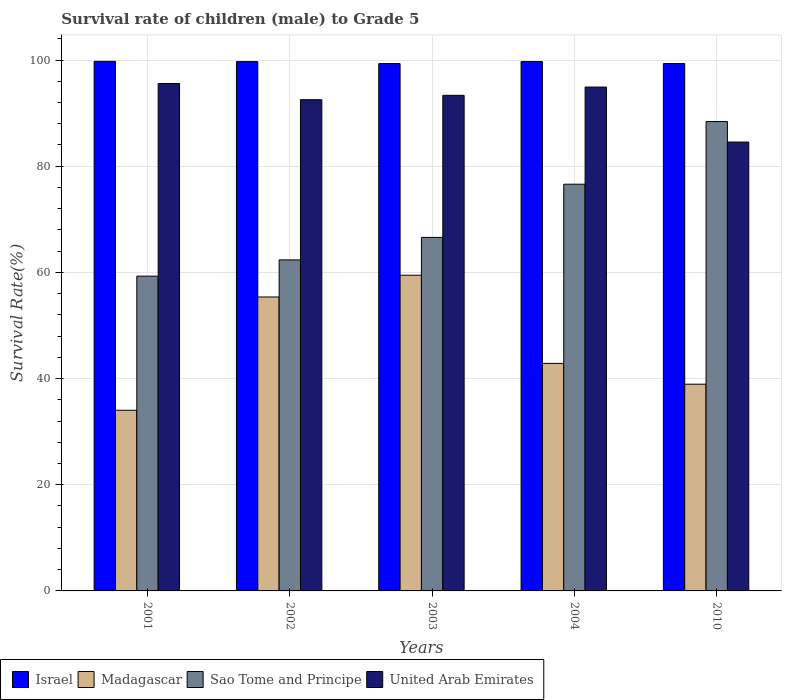How many groups of bars are there?
Provide a short and direct response. 5. Are the number of bars per tick equal to the number of legend labels?
Keep it short and to the point. Yes. Are the number of bars on each tick of the X-axis equal?
Your answer should be very brief. Yes. How many bars are there on the 4th tick from the left?
Your answer should be compact. 4. How many bars are there on the 3rd tick from the right?
Make the answer very short. 4. What is the survival rate of male children to grade 5 in Israel in 2010?
Your answer should be very brief. 99.33. Across all years, what is the maximum survival rate of male children to grade 5 in Sao Tome and Principe?
Give a very brief answer. 88.42. Across all years, what is the minimum survival rate of male children to grade 5 in Sao Tome and Principe?
Keep it short and to the point. 59.29. What is the total survival rate of male children to grade 5 in Sao Tome and Principe in the graph?
Make the answer very short. 353.26. What is the difference between the survival rate of male children to grade 5 in Madagascar in 2001 and that in 2004?
Offer a terse response. -8.83. What is the difference between the survival rate of male children to grade 5 in Sao Tome and Principe in 2001 and the survival rate of male children to grade 5 in Israel in 2004?
Make the answer very short. -40.42. What is the average survival rate of male children to grade 5 in Sao Tome and Principe per year?
Offer a terse response. 70.65. In the year 2002, what is the difference between the survival rate of male children to grade 5 in Israel and survival rate of male children to grade 5 in Madagascar?
Your answer should be very brief. 44.34. In how many years, is the survival rate of male children to grade 5 in United Arab Emirates greater than 84 %?
Ensure brevity in your answer.  5. What is the ratio of the survival rate of male children to grade 5 in Sao Tome and Principe in 2003 to that in 2010?
Your answer should be compact. 0.75. Is the survival rate of male children to grade 5 in Israel in 2001 less than that in 2004?
Your answer should be compact. No. What is the difference between the highest and the second highest survival rate of male children to grade 5 in Madagascar?
Offer a very short reply. 4.1. What is the difference between the highest and the lowest survival rate of male children to grade 5 in Israel?
Ensure brevity in your answer.  0.42. In how many years, is the survival rate of male children to grade 5 in Madagascar greater than the average survival rate of male children to grade 5 in Madagascar taken over all years?
Your answer should be very brief. 2. Is the sum of the survival rate of male children to grade 5 in United Arab Emirates in 2002 and 2010 greater than the maximum survival rate of male children to grade 5 in Madagascar across all years?
Keep it short and to the point. Yes. Is it the case that in every year, the sum of the survival rate of male children to grade 5 in United Arab Emirates and survival rate of male children to grade 5 in Madagascar is greater than the sum of survival rate of male children to grade 5 in Sao Tome and Principe and survival rate of male children to grade 5 in Israel?
Provide a succinct answer. Yes. What does the 4th bar from the left in 2001 represents?
Your answer should be very brief. United Arab Emirates. Are all the bars in the graph horizontal?
Make the answer very short. No. How many years are there in the graph?
Provide a succinct answer. 5. What is the difference between two consecutive major ticks on the Y-axis?
Keep it short and to the point. 20. What is the title of the graph?
Give a very brief answer. Survival rate of children (male) to Grade 5. What is the label or title of the X-axis?
Offer a very short reply. Years. What is the label or title of the Y-axis?
Provide a short and direct response. Survival Rate(%). What is the Survival Rate(%) in Israel in 2001?
Keep it short and to the point. 99.75. What is the Survival Rate(%) in Madagascar in 2001?
Offer a terse response. 34.03. What is the Survival Rate(%) of Sao Tome and Principe in 2001?
Offer a terse response. 59.29. What is the Survival Rate(%) of United Arab Emirates in 2001?
Offer a terse response. 95.57. What is the Survival Rate(%) in Israel in 2002?
Offer a very short reply. 99.71. What is the Survival Rate(%) of Madagascar in 2002?
Your response must be concise. 55.37. What is the Survival Rate(%) of Sao Tome and Principe in 2002?
Give a very brief answer. 62.35. What is the Survival Rate(%) of United Arab Emirates in 2002?
Make the answer very short. 92.53. What is the Survival Rate(%) of Israel in 2003?
Ensure brevity in your answer.  99.33. What is the Survival Rate(%) in Madagascar in 2003?
Your answer should be very brief. 59.47. What is the Survival Rate(%) in Sao Tome and Principe in 2003?
Provide a short and direct response. 66.59. What is the Survival Rate(%) in United Arab Emirates in 2003?
Offer a very short reply. 93.35. What is the Survival Rate(%) in Israel in 2004?
Give a very brief answer. 99.72. What is the Survival Rate(%) in Madagascar in 2004?
Provide a short and direct response. 42.86. What is the Survival Rate(%) in Sao Tome and Principe in 2004?
Offer a terse response. 76.61. What is the Survival Rate(%) in United Arab Emirates in 2004?
Keep it short and to the point. 94.91. What is the Survival Rate(%) in Israel in 2010?
Ensure brevity in your answer.  99.33. What is the Survival Rate(%) of Madagascar in 2010?
Give a very brief answer. 38.94. What is the Survival Rate(%) in Sao Tome and Principe in 2010?
Give a very brief answer. 88.42. What is the Survival Rate(%) of United Arab Emirates in 2010?
Make the answer very short. 84.55. Across all years, what is the maximum Survival Rate(%) of Israel?
Offer a very short reply. 99.75. Across all years, what is the maximum Survival Rate(%) in Madagascar?
Your answer should be very brief. 59.47. Across all years, what is the maximum Survival Rate(%) of Sao Tome and Principe?
Keep it short and to the point. 88.42. Across all years, what is the maximum Survival Rate(%) of United Arab Emirates?
Provide a short and direct response. 95.57. Across all years, what is the minimum Survival Rate(%) of Israel?
Make the answer very short. 99.33. Across all years, what is the minimum Survival Rate(%) of Madagascar?
Ensure brevity in your answer.  34.03. Across all years, what is the minimum Survival Rate(%) of Sao Tome and Principe?
Offer a terse response. 59.29. Across all years, what is the minimum Survival Rate(%) of United Arab Emirates?
Provide a succinct answer. 84.55. What is the total Survival Rate(%) of Israel in the graph?
Offer a terse response. 497.84. What is the total Survival Rate(%) of Madagascar in the graph?
Ensure brevity in your answer.  230.66. What is the total Survival Rate(%) of Sao Tome and Principe in the graph?
Offer a terse response. 353.26. What is the total Survival Rate(%) in United Arab Emirates in the graph?
Offer a terse response. 460.92. What is the difference between the Survival Rate(%) of Israel in 2001 and that in 2002?
Offer a very short reply. 0.05. What is the difference between the Survival Rate(%) in Madagascar in 2001 and that in 2002?
Keep it short and to the point. -21.34. What is the difference between the Survival Rate(%) in Sao Tome and Principe in 2001 and that in 2002?
Keep it short and to the point. -3.06. What is the difference between the Survival Rate(%) of United Arab Emirates in 2001 and that in 2002?
Provide a succinct answer. 3.04. What is the difference between the Survival Rate(%) in Israel in 2001 and that in 2003?
Provide a short and direct response. 0.42. What is the difference between the Survival Rate(%) in Madagascar in 2001 and that in 2003?
Your response must be concise. -25.44. What is the difference between the Survival Rate(%) of Sao Tome and Principe in 2001 and that in 2003?
Your answer should be very brief. -7.3. What is the difference between the Survival Rate(%) in United Arab Emirates in 2001 and that in 2003?
Make the answer very short. 2.22. What is the difference between the Survival Rate(%) of Israel in 2001 and that in 2004?
Keep it short and to the point. 0.04. What is the difference between the Survival Rate(%) of Madagascar in 2001 and that in 2004?
Offer a very short reply. -8.83. What is the difference between the Survival Rate(%) in Sao Tome and Principe in 2001 and that in 2004?
Ensure brevity in your answer.  -17.32. What is the difference between the Survival Rate(%) in United Arab Emirates in 2001 and that in 2004?
Provide a succinct answer. 0.66. What is the difference between the Survival Rate(%) of Israel in 2001 and that in 2010?
Provide a short and direct response. 0.42. What is the difference between the Survival Rate(%) in Madagascar in 2001 and that in 2010?
Provide a short and direct response. -4.91. What is the difference between the Survival Rate(%) of Sao Tome and Principe in 2001 and that in 2010?
Give a very brief answer. -29.13. What is the difference between the Survival Rate(%) of United Arab Emirates in 2001 and that in 2010?
Your answer should be very brief. 11.03. What is the difference between the Survival Rate(%) in Israel in 2002 and that in 2003?
Ensure brevity in your answer.  0.37. What is the difference between the Survival Rate(%) of Madagascar in 2002 and that in 2003?
Give a very brief answer. -4.1. What is the difference between the Survival Rate(%) of Sao Tome and Principe in 2002 and that in 2003?
Your answer should be compact. -4.24. What is the difference between the Survival Rate(%) of United Arab Emirates in 2002 and that in 2003?
Your response must be concise. -0.82. What is the difference between the Survival Rate(%) in Israel in 2002 and that in 2004?
Provide a short and direct response. -0.01. What is the difference between the Survival Rate(%) of Madagascar in 2002 and that in 2004?
Offer a very short reply. 12.51. What is the difference between the Survival Rate(%) of Sao Tome and Principe in 2002 and that in 2004?
Ensure brevity in your answer.  -14.26. What is the difference between the Survival Rate(%) of United Arab Emirates in 2002 and that in 2004?
Your response must be concise. -2.38. What is the difference between the Survival Rate(%) of Israel in 2002 and that in 2010?
Offer a very short reply. 0.37. What is the difference between the Survival Rate(%) in Madagascar in 2002 and that in 2010?
Ensure brevity in your answer.  16.43. What is the difference between the Survival Rate(%) of Sao Tome and Principe in 2002 and that in 2010?
Provide a short and direct response. -26.07. What is the difference between the Survival Rate(%) in United Arab Emirates in 2002 and that in 2010?
Your response must be concise. 7.98. What is the difference between the Survival Rate(%) in Israel in 2003 and that in 2004?
Your answer should be compact. -0.39. What is the difference between the Survival Rate(%) in Madagascar in 2003 and that in 2004?
Make the answer very short. 16.61. What is the difference between the Survival Rate(%) of Sao Tome and Principe in 2003 and that in 2004?
Ensure brevity in your answer.  -10.02. What is the difference between the Survival Rate(%) of United Arab Emirates in 2003 and that in 2004?
Offer a very short reply. -1.56. What is the difference between the Survival Rate(%) in Israel in 2003 and that in 2010?
Make the answer very short. -0. What is the difference between the Survival Rate(%) of Madagascar in 2003 and that in 2010?
Offer a very short reply. 20.53. What is the difference between the Survival Rate(%) in Sao Tome and Principe in 2003 and that in 2010?
Make the answer very short. -21.83. What is the difference between the Survival Rate(%) of United Arab Emirates in 2003 and that in 2010?
Offer a terse response. 8.8. What is the difference between the Survival Rate(%) in Israel in 2004 and that in 2010?
Keep it short and to the point. 0.38. What is the difference between the Survival Rate(%) of Madagascar in 2004 and that in 2010?
Provide a succinct answer. 3.92. What is the difference between the Survival Rate(%) of Sao Tome and Principe in 2004 and that in 2010?
Your answer should be compact. -11.81. What is the difference between the Survival Rate(%) in United Arab Emirates in 2004 and that in 2010?
Offer a terse response. 10.36. What is the difference between the Survival Rate(%) of Israel in 2001 and the Survival Rate(%) of Madagascar in 2002?
Provide a succinct answer. 44.38. What is the difference between the Survival Rate(%) of Israel in 2001 and the Survival Rate(%) of Sao Tome and Principe in 2002?
Provide a short and direct response. 37.4. What is the difference between the Survival Rate(%) in Israel in 2001 and the Survival Rate(%) in United Arab Emirates in 2002?
Offer a very short reply. 7.22. What is the difference between the Survival Rate(%) of Madagascar in 2001 and the Survival Rate(%) of Sao Tome and Principe in 2002?
Provide a short and direct response. -28.32. What is the difference between the Survival Rate(%) of Madagascar in 2001 and the Survival Rate(%) of United Arab Emirates in 2002?
Give a very brief answer. -58.5. What is the difference between the Survival Rate(%) of Sao Tome and Principe in 2001 and the Survival Rate(%) of United Arab Emirates in 2002?
Provide a short and direct response. -33.24. What is the difference between the Survival Rate(%) of Israel in 2001 and the Survival Rate(%) of Madagascar in 2003?
Your answer should be compact. 40.29. What is the difference between the Survival Rate(%) of Israel in 2001 and the Survival Rate(%) of Sao Tome and Principe in 2003?
Offer a very short reply. 33.16. What is the difference between the Survival Rate(%) in Israel in 2001 and the Survival Rate(%) in United Arab Emirates in 2003?
Make the answer very short. 6.4. What is the difference between the Survival Rate(%) in Madagascar in 2001 and the Survival Rate(%) in Sao Tome and Principe in 2003?
Give a very brief answer. -32.56. What is the difference between the Survival Rate(%) in Madagascar in 2001 and the Survival Rate(%) in United Arab Emirates in 2003?
Make the answer very short. -59.32. What is the difference between the Survival Rate(%) in Sao Tome and Principe in 2001 and the Survival Rate(%) in United Arab Emirates in 2003?
Provide a short and direct response. -34.06. What is the difference between the Survival Rate(%) in Israel in 2001 and the Survival Rate(%) in Madagascar in 2004?
Your response must be concise. 56.89. What is the difference between the Survival Rate(%) of Israel in 2001 and the Survival Rate(%) of Sao Tome and Principe in 2004?
Ensure brevity in your answer.  23.14. What is the difference between the Survival Rate(%) in Israel in 2001 and the Survival Rate(%) in United Arab Emirates in 2004?
Keep it short and to the point. 4.84. What is the difference between the Survival Rate(%) in Madagascar in 2001 and the Survival Rate(%) in Sao Tome and Principe in 2004?
Give a very brief answer. -42.58. What is the difference between the Survival Rate(%) in Madagascar in 2001 and the Survival Rate(%) in United Arab Emirates in 2004?
Your answer should be very brief. -60.88. What is the difference between the Survival Rate(%) of Sao Tome and Principe in 2001 and the Survival Rate(%) of United Arab Emirates in 2004?
Provide a succinct answer. -35.62. What is the difference between the Survival Rate(%) of Israel in 2001 and the Survival Rate(%) of Madagascar in 2010?
Make the answer very short. 60.81. What is the difference between the Survival Rate(%) in Israel in 2001 and the Survival Rate(%) in Sao Tome and Principe in 2010?
Ensure brevity in your answer.  11.33. What is the difference between the Survival Rate(%) in Israel in 2001 and the Survival Rate(%) in United Arab Emirates in 2010?
Keep it short and to the point. 15.2. What is the difference between the Survival Rate(%) of Madagascar in 2001 and the Survival Rate(%) of Sao Tome and Principe in 2010?
Offer a terse response. -54.39. What is the difference between the Survival Rate(%) in Madagascar in 2001 and the Survival Rate(%) in United Arab Emirates in 2010?
Give a very brief answer. -50.52. What is the difference between the Survival Rate(%) in Sao Tome and Principe in 2001 and the Survival Rate(%) in United Arab Emirates in 2010?
Offer a terse response. -25.26. What is the difference between the Survival Rate(%) of Israel in 2002 and the Survival Rate(%) of Madagascar in 2003?
Your answer should be very brief. 40.24. What is the difference between the Survival Rate(%) in Israel in 2002 and the Survival Rate(%) in Sao Tome and Principe in 2003?
Keep it short and to the point. 33.12. What is the difference between the Survival Rate(%) in Israel in 2002 and the Survival Rate(%) in United Arab Emirates in 2003?
Provide a short and direct response. 6.35. What is the difference between the Survival Rate(%) of Madagascar in 2002 and the Survival Rate(%) of Sao Tome and Principe in 2003?
Make the answer very short. -11.22. What is the difference between the Survival Rate(%) of Madagascar in 2002 and the Survival Rate(%) of United Arab Emirates in 2003?
Ensure brevity in your answer.  -37.99. What is the difference between the Survival Rate(%) in Sao Tome and Principe in 2002 and the Survival Rate(%) in United Arab Emirates in 2003?
Provide a succinct answer. -31. What is the difference between the Survival Rate(%) in Israel in 2002 and the Survival Rate(%) in Madagascar in 2004?
Ensure brevity in your answer.  56.85. What is the difference between the Survival Rate(%) of Israel in 2002 and the Survival Rate(%) of Sao Tome and Principe in 2004?
Provide a short and direct response. 23.09. What is the difference between the Survival Rate(%) of Israel in 2002 and the Survival Rate(%) of United Arab Emirates in 2004?
Keep it short and to the point. 4.8. What is the difference between the Survival Rate(%) in Madagascar in 2002 and the Survival Rate(%) in Sao Tome and Principe in 2004?
Keep it short and to the point. -21.24. What is the difference between the Survival Rate(%) in Madagascar in 2002 and the Survival Rate(%) in United Arab Emirates in 2004?
Provide a short and direct response. -39.54. What is the difference between the Survival Rate(%) of Sao Tome and Principe in 2002 and the Survival Rate(%) of United Arab Emirates in 2004?
Offer a very short reply. -32.56. What is the difference between the Survival Rate(%) of Israel in 2002 and the Survival Rate(%) of Madagascar in 2010?
Offer a very short reply. 60.77. What is the difference between the Survival Rate(%) of Israel in 2002 and the Survival Rate(%) of Sao Tome and Principe in 2010?
Your response must be concise. 11.29. What is the difference between the Survival Rate(%) in Israel in 2002 and the Survival Rate(%) in United Arab Emirates in 2010?
Offer a terse response. 15.16. What is the difference between the Survival Rate(%) in Madagascar in 2002 and the Survival Rate(%) in Sao Tome and Principe in 2010?
Offer a very short reply. -33.05. What is the difference between the Survival Rate(%) in Madagascar in 2002 and the Survival Rate(%) in United Arab Emirates in 2010?
Your response must be concise. -29.18. What is the difference between the Survival Rate(%) in Sao Tome and Principe in 2002 and the Survival Rate(%) in United Arab Emirates in 2010?
Your answer should be very brief. -22.2. What is the difference between the Survival Rate(%) in Israel in 2003 and the Survival Rate(%) in Madagascar in 2004?
Give a very brief answer. 56.47. What is the difference between the Survival Rate(%) of Israel in 2003 and the Survival Rate(%) of Sao Tome and Principe in 2004?
Keep it short and to the point. 22.72. What is the difference between the Survival Rate(%) of Israel in 2003 and the Survival Rate(%) of United Arab Emirates in 2004?
Give a very brief answer. 4.42. What is the difference between the Survival Rate(%) in Madagascar in 2003 and the Survival Rate(%) in Sao Tome and Principe in 2004?
Provide a succinct answer. -17.15. What is the difference between the Survival Rate(%) in Madagascar in 2003 and the Survival Rate(%) in United Arab Emirates in 2004?
Your response must be concise. -35.44. What is the difference between the Survival Rate(%) in Sao Tome and Principe in 2003 and the Survival Rate(%) in United Arab Emirates in 2004?
Keep it short and to the point. -28.32. What is the difference between the Survival Rate(%) of Israel in 2003 and the Survival Rate(%) of Madagascar in 2010?
Provide a succinct answer. 60.39. What is the difference between the Survival Rate(%) in Israel in 2003 and the Survival Rate(%) in Sao Tome and Principe in 2010?
Provide a succinct answer. 10.91. What is the difference between the Survival Rate(%) of Israel in 2003 and the Survival Rate(%) of United Arab Emirates in 2010?
Your answer should be very brief. 14.78. What is the difference between the Survival Rate(%) in Madagascar in 2003 and the Survival Rate(%) in Sao Tome and Principe in 2010?
Your answer should be compact. -28.95. What is the difference between the Survival Rate(%) of Madagascar in 2003 and the Survival Rate(%) of United Arab Emirates in 2010?
Your response must be concise. -25.08. What is the difference between the Survival Rate(%) in Sao Tome and Principe in 2003 and the Survival Rate(%) in United Arab Emirates in 2010?
Offer a terse response. -17.96. What is the difference between the Survival Rate(%) of Israel in 2004 and the Survival Rate(%) of Madagascar in 2010?
Your answer should be compact. 60.78. What is the difference between the Survival Rate(%) of Israel in 2004 and the Survival Rate(%) of Sao Tome and Principe in 2010?
Provide a succinct answer. 11.3. What is the difference between the Survival Rate(%) in Israel in 2004 and the Survival Rate(%) in United Arab Emirates in 2010?
Give a very brief answer. 15.17. What is the difference between the Survival Rate(%) in Madagascar in 2004 and the Survival Rate(%) in Sao Tome and Principe in 2010?
Your response must be concise. -45.56. What is the difference between the Survival Rate(%) of Madagascar in 2004 and the Survival Rate(%) of United Arab Emirates in 2010?
Give a very brief answer. -41.69. What is the difference between the Survival Rate(%) in Sao Tome and Principe in 2004 and the Survival Rate(%) in United Arab Emirates in 2010?
Make the answer very short. -7.94. What is the average Survival Rate(%) in Israel per year?
Provide a short and direct response. 99.57. What is the average Survival Rate(%) in Madagascar per year?
Your answer should be compact. 46.13. What is the average Survival Rate(%) in Sao Tome and Principe per year?
Provide a short and direct response. 70.65. What is the average Survival Rate(%) of United Arab Emirates per year?
Your answer should be compact. 92.18. In the year 2001, what is the difference between the Survival Rate(%) in Israel and Survival Rate(%) in Madagascar?
Your response must be concise. 65.72. In the year 2001, what is the difference between the Survival Rate(%) in Israel and Survival Rate(%) in Sao Tome and Principe?
Make the answer very short. 40.46. In the year 2001, what is the difference between the Survival Rate(%) in Israel and Survival Rate(%) in United Arab Emirates?
Make the answer very short. 4.18. In the year 2001, what is the difference between the Survival Rate(%) in Madagascar and Survival Rate(%) in Sao Tome and Principe?
Offer a terse response. -25.26. In the year 2001, what is the difference between the Survival Rate(%) in Madagascar and Survival Rate(%) in United Arab Emirates?
Make the answer very short. -61.54. In the year 2001, what is the difference between the Survival Rate(%) in Sao Tome and Principe and Survival Rate(%) in United Arab Emirates?
Ensure brevity in your answer.  -36.28. In the year 2002, what is the difference between the Survival Rate(%) in Israel and Survival Rate(%) in Madagascar?
Keep it short and to the point. 44.34. In the year 2002, what is the difference between the Survival Rate(%) in Israel and Survival Rate(%) in Sao Tome and Principe?
Give a very brief answer. 37.35. In the year 2002, what is the difference between the Survival Rate(%) of Israel and Survival Rate(%) of United Arab Emirates?
Provide a short and direct response. 7.18. In the year 2002, what is the difference between the Survival Rate(%) in Madagascar and Survival Rate(%) in Sao Tome and Principe?
Offer a terse response. -6.98. In the year 2002, what is the difference between the Survival Rate(%) in Madagascar and Survival Rate(%) in United Arab Emirates?
Provide a short and direct response. -37.16. In the year 2002, what is the difference between the Survival Rate(%) of Sao Tome and Principe and Survival Rate(%) of United Arab Emirates?
Your answer should be very brief. -30.18. In the year 2003, what is the difference between the Survival Rate(%) of Israel and Survival Rate(%) of Madagascar?
Provide a succinct answer. 39.86. In the year 2003, what is the difference between the Survival Rate(%) in Israel and Survival Rate(%) in Sao Tome and Principe?
Offer a very short reply. 32.74. In the year 2003, what is the difference between the Survival Rate(%) in Israel and Survival Rate(%) in United Arab Emirates?
Make the answer very short. 5.98. In the year 2003, what is the difference between the Survival Rate(%) in Madagascar and Survival Rate(%) in Sao Tome and Principe?
Your answer should be very brief. -7.12. In the year 2003, what is the difference between the Survival Rate(%) in Madagascar and Survival Rate(%) in United Arab Emirates?
Your response must be concise. -33.89. In the year 2003, what is the difference between the Survival Rate(%) in Sao Tome and Principe and Survival Rate(%) in United Arab Emirates?
Your response must be concise. -26.76. In the year 2004, what is the difference between the Survival Rate(%) in Israel and Survival Rate(%) in Madagascar?
Make the answer very short. 56.86. In the year 2004, what is the difference between the Survival Rate(%) in Israel and Survival Rate(%) in Sao Tome and Principe?
Keep it short and to the point. 23.1. In the year 2004, what is the difference between the Survival Rate(%) of Israel and Survival Rate(%) of United Arab Emirates?
Your response must be concise. 4.81. In the year 2004, what is the difference between the Survival Rate(%) of Madagascar and Survival Rate(%) of Sao Tome and Principe?
Keep it short and to the point. -33.75. In the year 2004, what is the difference between the Survival Rate(%) in Madagascar and Survival Rate(%) in United Arab Emirates?
Give a very brief answer. -52.05. In the year 2004, what is the difference between the Survival Rate(%) of Sao Tome and Principe and Survival Rate(%) of United Arab Emirates?
Provide a succinct answer. -18.3. In the year 2010, what is the difference between the Survival Rate(%) of Israel and Survival Rate(%) of Madagascar?
Your answer should be very brief. 60.39. In the year 2010, what is the difference between the Survival Rate(%) in Israel and Survival Rate(%) in Sao Tome and Principe?
Your response must be concise. 10.91. In the year 2010, what is the difference between the Survival Rate(%) of Israel and Survival Rate(%) of United Arab Emirates?
Give a very brief answer. 14.78. In the year 2010, what is the difference between the Survival Rate(%) of Madagascar and Survival Rate(%) of Sao Tome and Principe?
Provide a short and direct response. -49.48. In the year 2010, what is the difference between the Survival Rate(%) in Madagascar and Survival Rate(%) in United Arab Emirates?
Provide a short and direct response. -45.61. In the year 2010, what is the difference between the Survival Rate(%) in Sao Tome and Principe and Survival Rate(%) in United Arab Emirates?
Keep it short and to the point. 3.87. What is the ratio of the Survival Rate(%) in Israel in 2001 to that in 2002?
Your response must be concise. 1. What is the ratio of the Survival Rate(%) of Madagascar in 2001 to that in 2002?
Provide a short and direct response. 0.61. What is the ratio of the Survival Rate(%) of Sao Tome and Principe in 2001 to that in 2002?
Offer a very short reply. 0.95. What is the ratio of the Survival Rate(%) of United Arab Emirates in 2001 to that in 2002?
Provide a short and direct response. 1.03. What is the ratio of the Survival Rate(%) of Madagascar in 2001 to that in 2003?
Provide a short and direct response. 0.57. What is the ratio of the Survival Rate(%) in Sao Tome and Principe in 2001 to that in 2003?
Make the answer very short. 0.89. What is the ratio of the Survival Rate(%) in United Arab Emirates in 2001 to that in 2003?
Keep it short and to the point. 1.02. What is the ratio of the Survival Rate(%) of Madagascar in 2001 to that in 2004?
Give a very brief answer. 0.79. What is the ratio of the Survival Rate(%) of Sao Tome and Principe in 2001 to that in 2004?
Ensure brevity in your answer.  0.77. What is the ratio of the Survival Rate(%) of Madagascar in 2001 to that in 2010?
Offer a terse response. 0.87. What is the ratio of the Survival Rate(%) in Sao Tome and Principe in 2001 to that in 2010?
Make the answer very short. 0.67. What is the ratio of the Survival Rate(%) of United Arab Emirates in 2001 to that in 2010?
Offer a terse response. 1.13. What is the ratio of the Survival Rate(%) of Israel in 2002 to that in 2003?
Give a very brief answer. 1. What is the ratio of the Survival Rate(%) in Madagascar in 2002 to that in 2003?
Make the answer very short. 0.93. What is the ratio of the Survival Rate(%) in Sao Tome and Principe in 2002 to that in 2003?
Offer a very short reply. 0.94. What is the ratio of the Survival Rate(%) in Israel in 2002 to that in 2004?
Your answer should be very brief. 1. What is the ratio of the Survival Rate(%) in Madagascar in 2002 to that in 2004?
Provide a short and direct response. 1.29. What is the ratio of the Survival Rate(%) of Sao Tome and Principe in 2002 to that in 2004?
Give a very brief answer. 0.81. What is the ratio of the Survival Rate(%) of United Arab Emirates in 2002 to that in 2004?
Provide a succinct answer. 0.97. What is the ratio of the Survival Rate(%) in Israel in 2002 to that in 2010?
Make the answer very short. 1. What is the ratio of the Survival Rate(%) of Madagascar in 2002 to that in 2010?
Give a very brief answer. 1.42. What is the ratio of the Survival Rate(%) in Sao Tome and Principe in 2002 to that in 2010?
Keep it short and to the point. 0.71. What is the ratio of the Survival Rate(%) of United Arab Emirates in 2002 to that in 2010?
Provide a short and direct response. 1.09. What is the ratio of the Survival Rate(%) of Israel in 2003 to that in 2004?
Keep it short and to the point. 1. What is the ratio of the Survival Rate(%) in Madagascar in 2003 to that in 2004?
Provide a short and direct response. 1.39. What is the ratio of the Survival Rate(%) in Sao Tome and Principe in 2003 to that in 2004?
Give a very brief answer. 0.87. What is the ratio of the Survival Rate(%) in United Arab Emirates in 2003 to that in 2004?
Your response must be concise. 0.98. What is the ratio of the Survival Rate(%) of Madagascar in 2003 to that in 2010?
Provide a short and direct response. 1.53. What is the ratio of the Survival Rate(%) of Sao Tome and Principe in 2003 to that in 2010?
Keep it short and to the point. 0.75. What is the ratio of the Survival Rate(%) in United Arab Emirates in 2003 to that in 2010?
Your answer should be very brief. 1.1. What is the ratio of the Survival Rate(%) in Madagascar in 2004 to that in 2010?
Ensure brevity in your answer.  1.1. What is the ratio of the Survival Rate(%) of Sao Tome and Principe in 2004 to that in 2010?
Give a very brief answer. 0.87. What is the ratio of the Survival Rate(%) in United Arab Emirates in 2004 to that in 2010?
Provide a short and direct response. 1.12. What is the difference between the highest and the second highest Survival Rate(%) in Israel?
Give a very brief answer. 0.04. What is the difference between the highest and the second highest Survival Rate(%) in Madagascar?
Offer a terse response. 4.1. What is the difference between the highest and the second highest Survival Rate(%) of Sao Tome and Principe?
Give a very brief answer. 11.81. What is the difference between the highest and the second highest Survival Rate(%) of United Arab Emirates?
Ensure brevity in your answer.  0.66. What is the difference between the highest and the lowest Survival Rate(%) in Israel?
Keep it short and to the point. 0.42. What is the difference between the highest and the lowest Survival Rate(%) in Madagascar?
Your response must be concise. 25.44. What is the difference between the highest and the lowest Survival Rate(%) of Sao Tome and Principe?
Provide a succinct answer. 29.13. What is the difference between the highest and the lowest Survival Rate(%) of United Arab Emirates?
Your response must be concise. 11.03. 